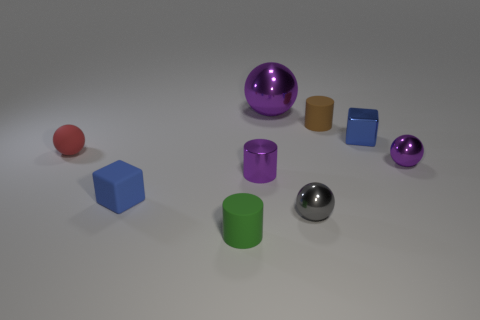Are there more gray balls that are left of the small purple metal sphere than cylinders?
Offer a very short reply. No. Is there any other thing that is the same color as the rubber cube?
Provide a short and direct response. Yes. There is a small green thing that is made of the same material as the brown object; what is its shape?
Provide a short and direct response. Cylinder. Is the purple object that is behind the tiny brown thing made of the same material as the gray thing?
Keep it short and to the point. Yes. What is the shape of the large thing that is the same color as the tiny metallic cylinder?
Give a very brief answer. Sphere. There is a tiny rubber object behind the tiny matte ball; is it the same color as the small cube that is in front of the blue shiny block?
Offer a very short reply. No. What number of purple things are on the left side of the big purple sphere and right of the small blue metallic object?
Ensure brevity in your answer.  0. What is the tiny gray object made of?
Offer a very short reply. Metal. What shape is the gray object that is the same size as the red thing?
Offer a very short reply. Sphere. Are the blue object behind the red object and the small ball that is on the left side of the big purple sphere made of the same material?
Keep it short and to the point. No. 